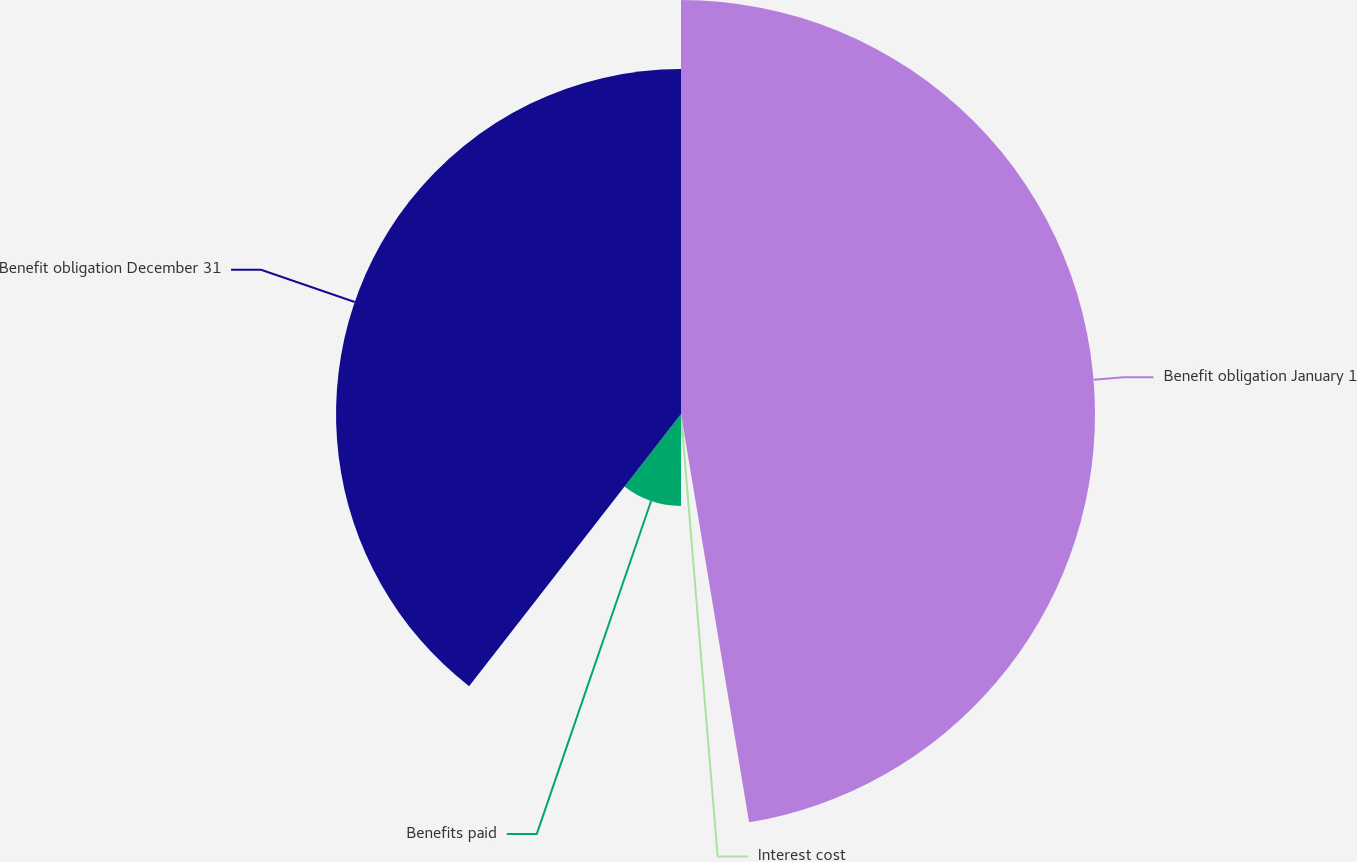Convert chart. <chart><loc_0><loc_0><loc_500><loc_500><pie_chart><fcel>Benefit obligation January 1<fcel>Interest cost<fcel>Benefits paid<fcel>Benefit obligation December 31<nl><fcel>47.37%<fcel>2.63%<fcel>10.53%<fcel>39.47%<nl></chart> 